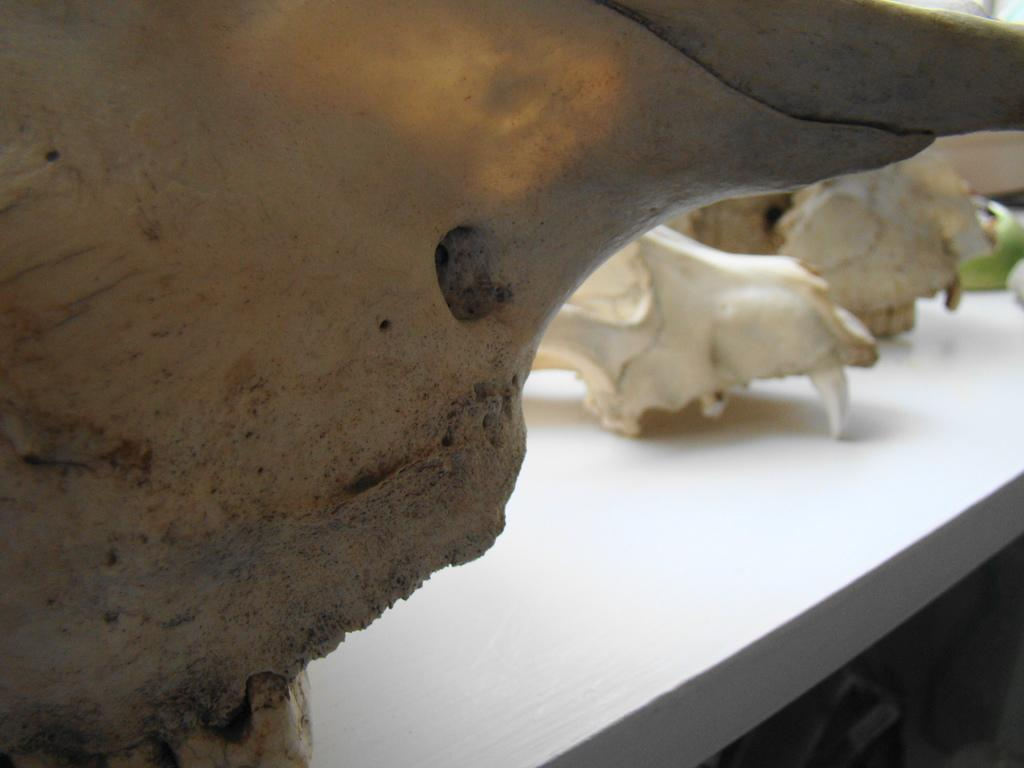What type of sea creatures are present in the image? There are manta rays in the image. What type of afterthought can be seen in the image? There is no afterthought present in the image, as it features manta rays in an underwater setting. 